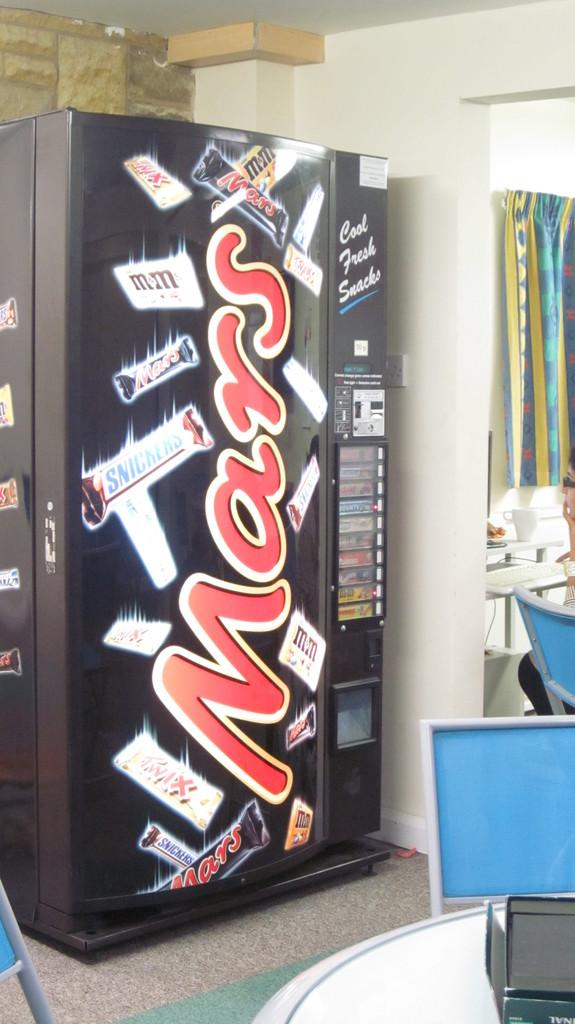<image>
Provide a brief description of the given image. A vending machine that has some chocolate bars such as Mars and snickers. 